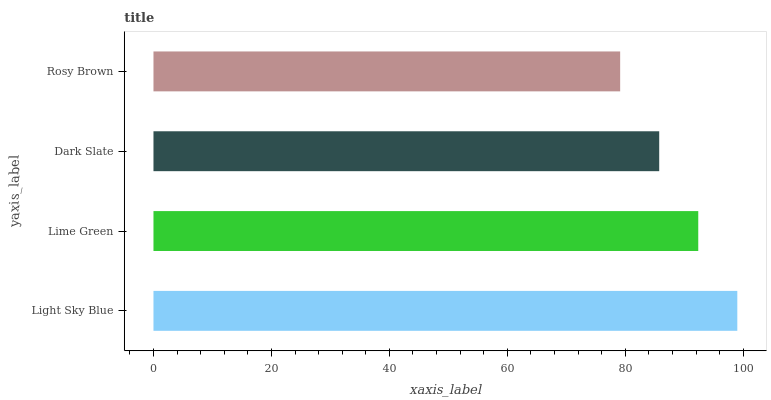Is Rosy Brown the minimum?
Answer yes or no. Yes. Is Light Sky Blue the maximum?
Answer yes or no. Yes. Is Lime Green the minimum?
Answer yes or no. No. Is Lime Green the maximum?
Answer yes or no. No. Is Light Sky Blue greater than Lime Green?
Answer yes or no. Yes. Is Lime Green less than Light Sky Blue?
Answer yes or no. Yes. Is Lime Green greater than Light Sky Blue?
Answer yes or no. No. Is Light Sky Blue less than Lime Green?
Answer yes or no. No. Is Lime Green the high median?
Answer yes or no. Yes. Is Dark Slate the low median?
Answer yes or no. Yes. Is Light Sky Blue the high median?
Answer yes or no. No. Is Rosy Brown the low median?
Answer yes or no. No. 